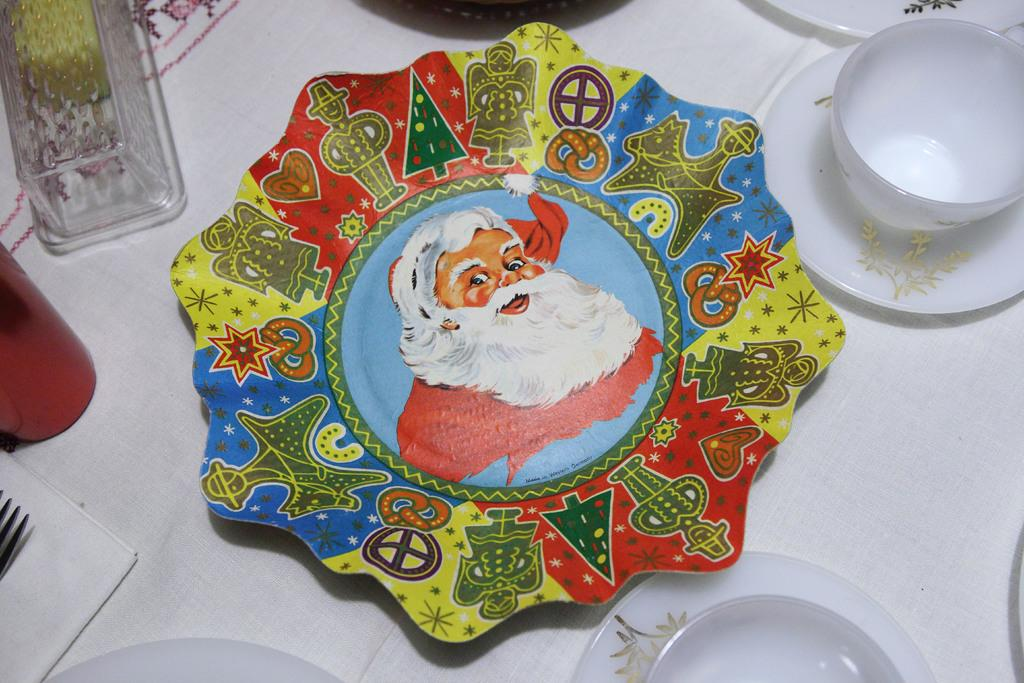What is on the plate in the image? There is a Santa Claus on the plate. What other items can be seen in the image? There is a cup, a saucer, multiple plates, a bottle, a glass, a fork, a tissue, and a white cloth in the image. What type of bells can be heard ringing in the image? There are no bells present in the image, and therefore no sound can be heard. 